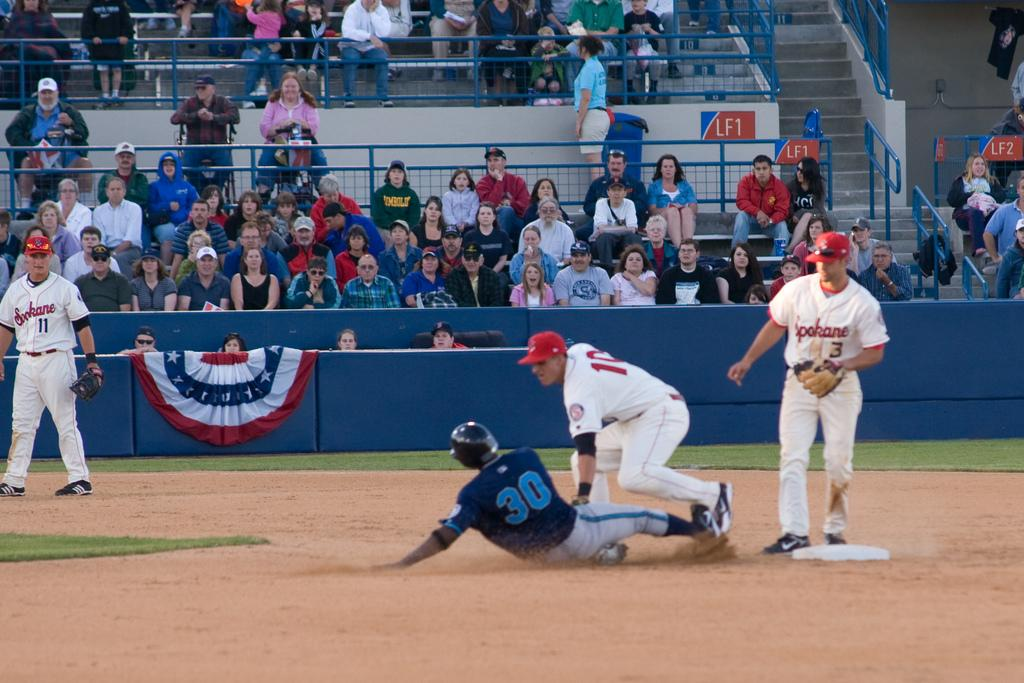<image>
Present a compact description of the photo's key features. A group of people playing baseball with some wearing Spokane jerseys. 